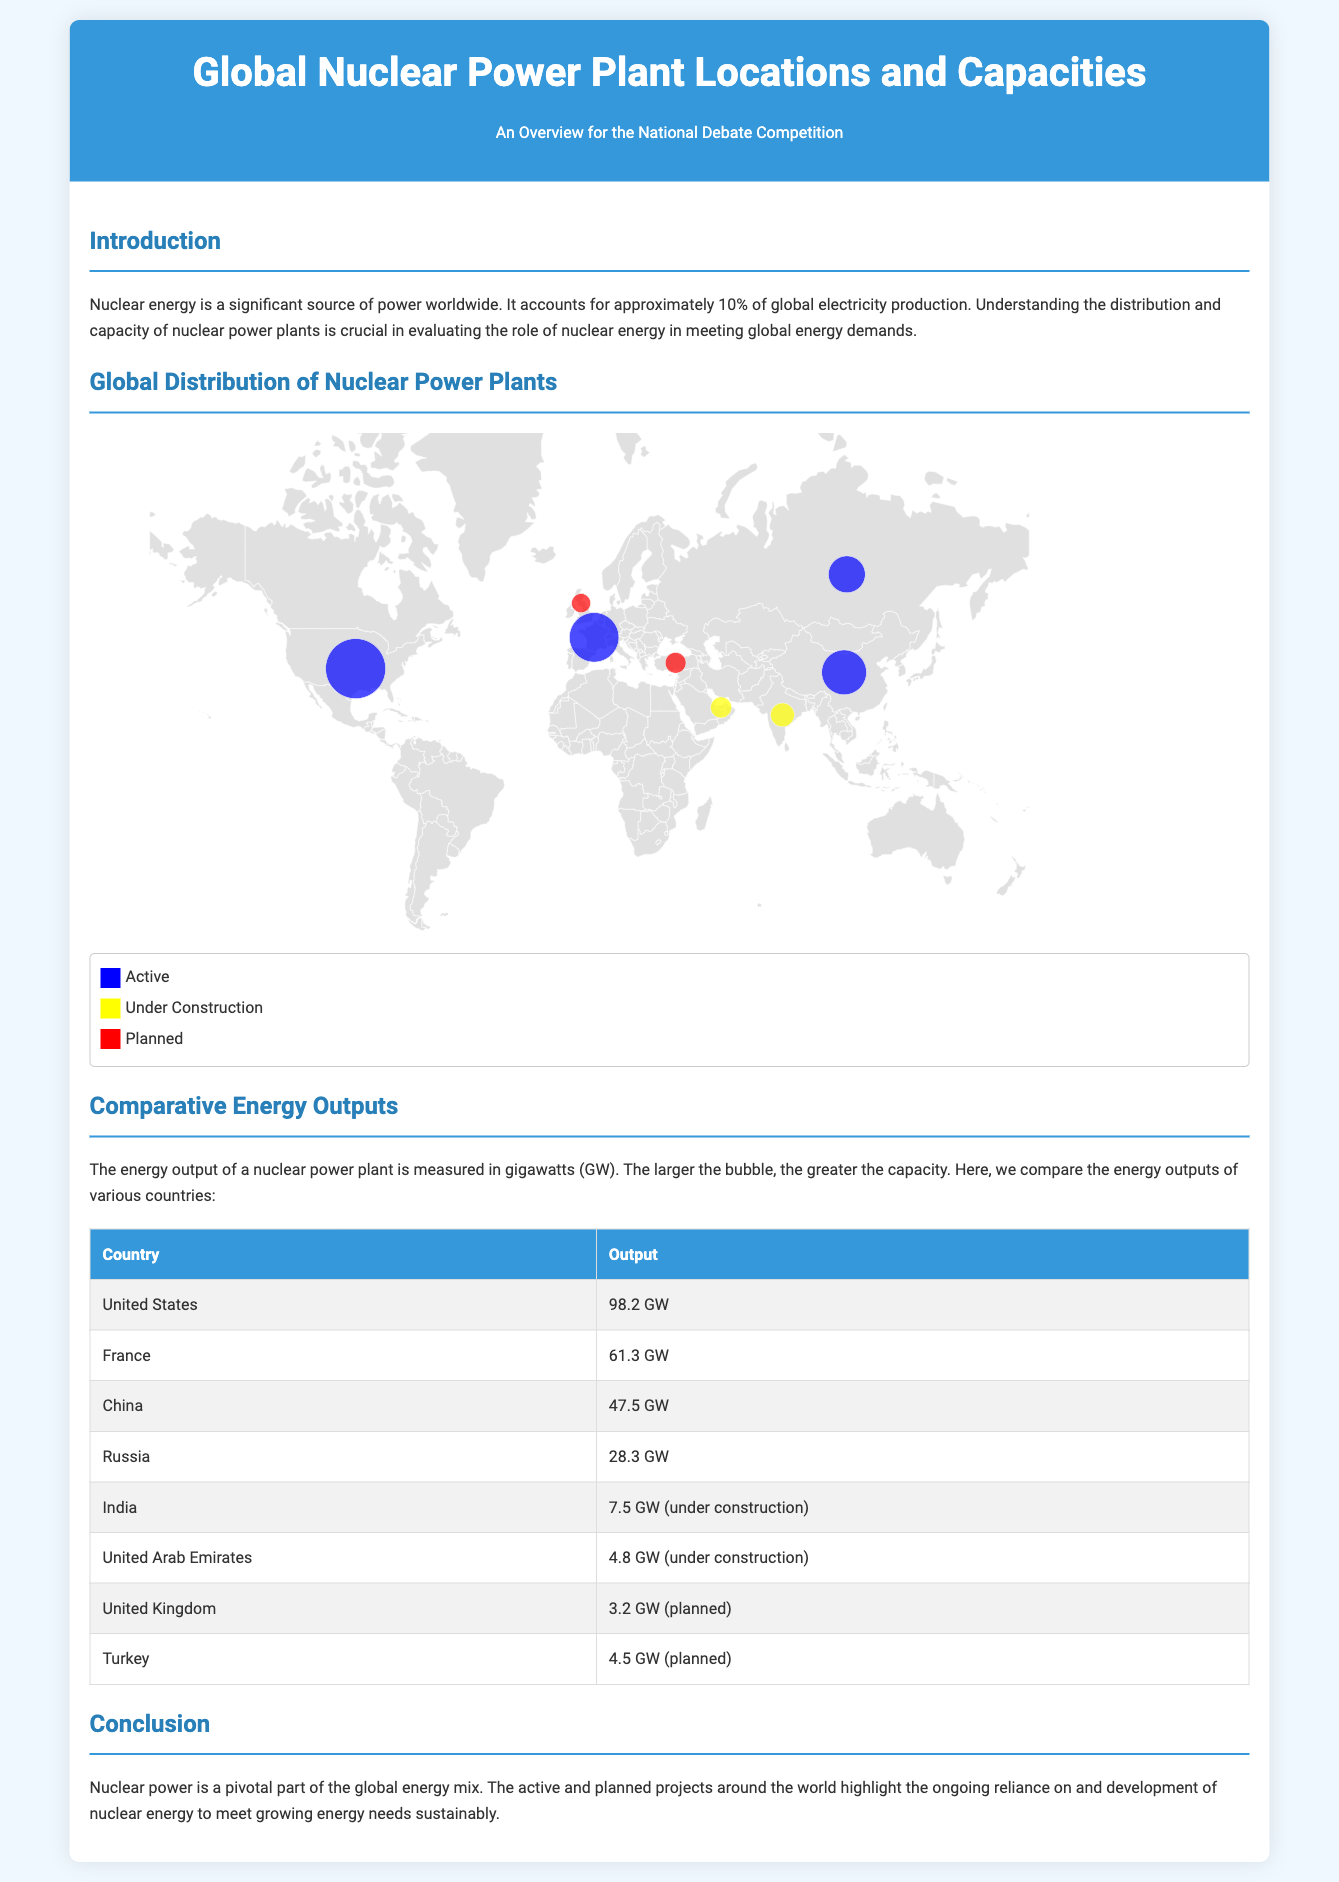What is the title of the document? The title is presented in the header section of the document, stating its subject clearly.
Answer: Global Nuclear Power Plant Locations and Capacities How many gigawatts is the nuclear output of the United States? The output is specifically listed in the comparative energy outputs table for the United States.
Answer: 98.2 GW Which country has a planned nuclear power capacity of 3.2 GW? The planned capacity is noted in the table comparing energy outputs.
Answer: United Kingdom What color represents nuclear power plants that are under construction? The legend describes the color coding for each operational status of the plants in the infographic.
Answer: Yellow Which country has the highest operational nuclear power capacity? The table lists the countries along with their capacities, showing which one has the highest.
Answer: United States What is the primary focus of the introduction section? The introduction outlines the role and significance of nuclear energy in global electricity production.
Answer: Nuclear energy is a significant source of power worldwide Which country has the nuclear output of 7.5 GW? The output is mentioned in the table, indicating the capacity and status of the country's nuclear power plants.
Answer: India What does the color blue represent in the legend? The legend defines the colors assigned to each status of nuclear power plants throughout the document.
Answer: Active How many countries are listed with under construction capacities? The comparative energy outputs section of the document contains a specific number of countries under that category.
Answer: 2 